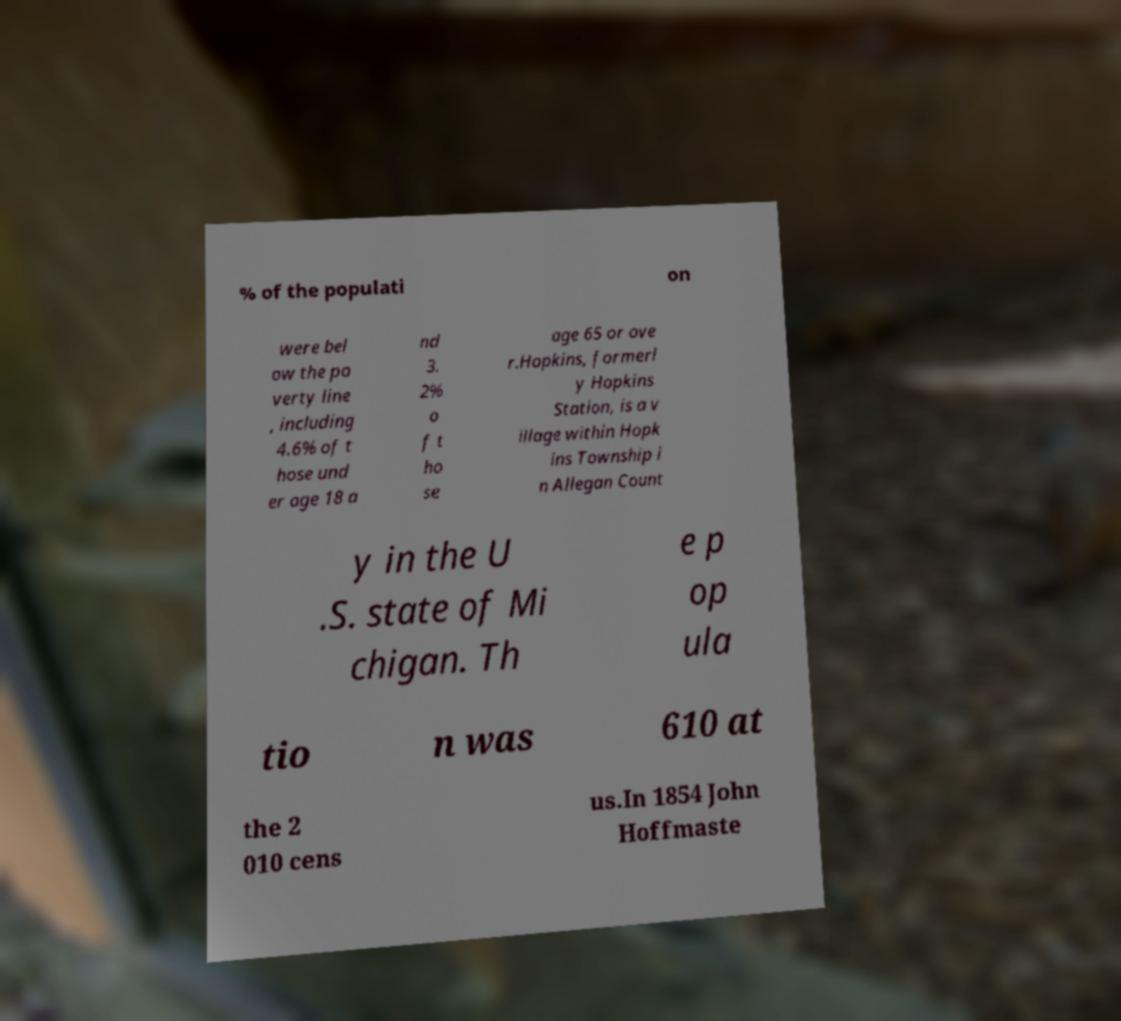I need the written content from this picture converted into text. Can you do that? % of the populati on were bel ow the po verty line , including 4.6% of t hose und er age 18 a nd 3. 2% o f t ho se age 65 or ove r.Hopkins, formerl y Hopkins Station, is a v illage within Hopk ins Township i n Allegan Count y in the U .S. state of Mi chigan. Th e p op ula tio n was 610 at the 2 010 cens us.In 1854 John Hoffmaste 